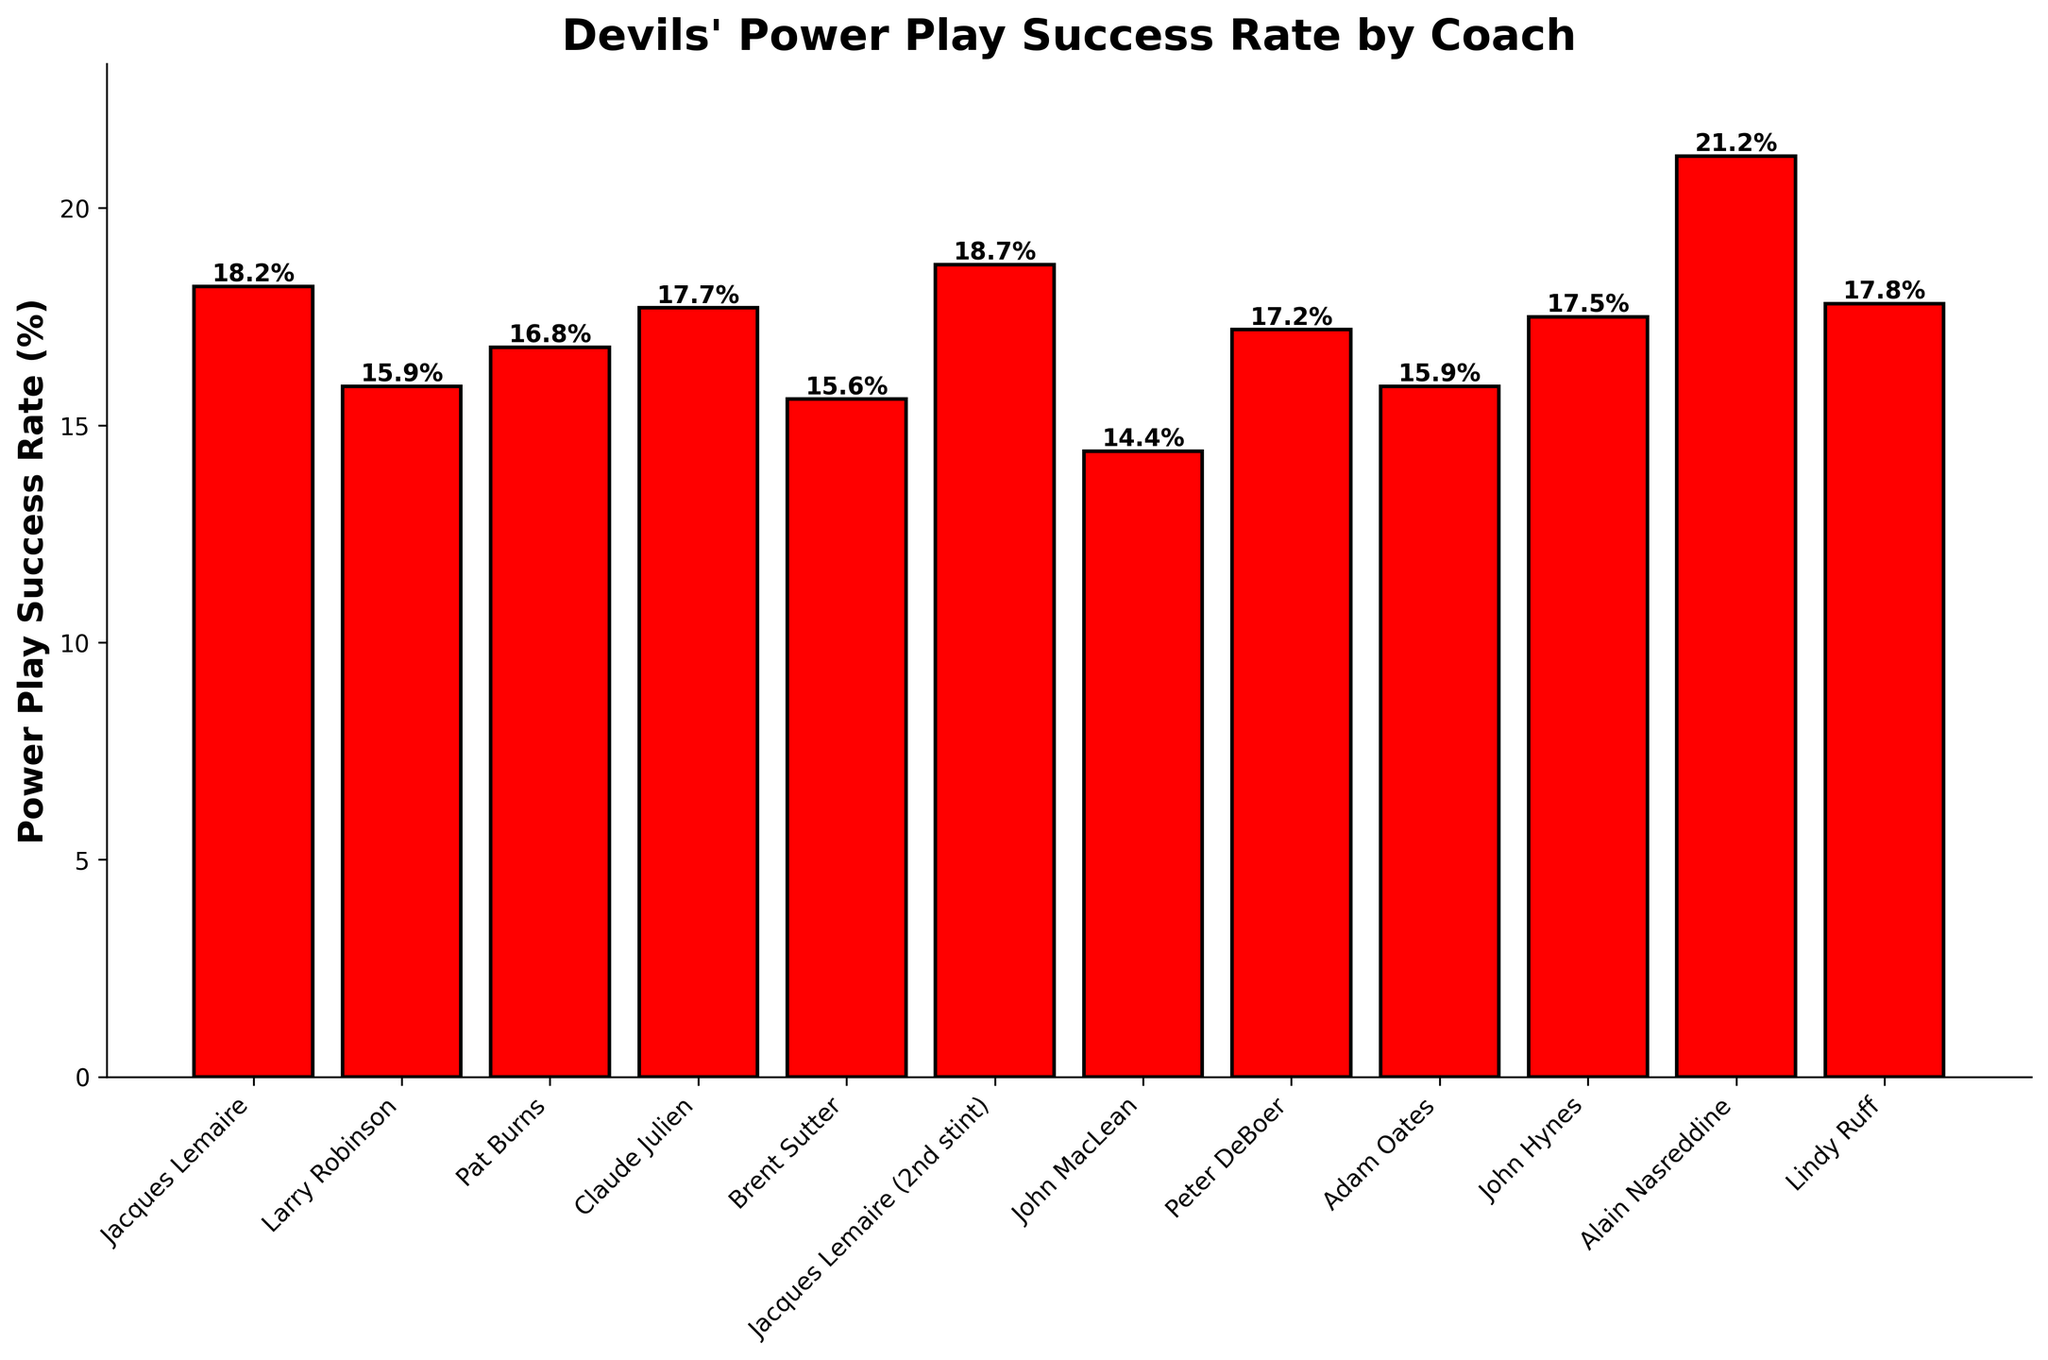Which coach had the highest power play success rate? To answer this, look at the heights of the bars. The highest bar represents the highest power play success rate. On this plot, the highest bar is labeled "Alain Nasreddine" with a success rate of 21.2%.
Answer: Alain Nasreddine What is the difference in power play success rates between Jacques Lemaire's first and second stints? Compare the heights of the two bars labeled "Jacques Lemaire" and "Jacques Lemaire (2nd stint)". First stint is 18.2% and second stint is 18.7%. The difference is 18.7% - 18.2% = 0.5%.
Answer: 0.5% Among Larry Robinson, Pat Burns, and Peter DeBoer, who had the lowest power play success rate? Compare the heights of the three bars labeled "Larry Robinson", "Pat Burns", and "Peter DeBoer". Their success rates are 15.9%, 16.8%, and 17.2%, respectively. The lowest is 15.9%, which belongs to Larry Robinson.
Answer: Larry Robinson Calculate the average power play success rate of all coaches. To find the average, add up all the success rates and divide by the number of coaches. The rates are 18.2%, 15.9%, 16.8%, 17.7%, 15.6%, 18.7%, 14.4%, 17.2%, 15.9%, 17.5%, 21.2%, 17.8%. Sum is 206.9%, and there are 12 coaches. The average is 206.9% / 12 ≈ 17.2%.
Answer: 17.2% Which coach had a power play success rate closest to 17.5%? Identify the bar that is closest in height to the line at 17.5%. The bars for Peter DeBoer (17.2%), John Hynes (17.5%), and Lindy Ruff (17.8%) are closest. John Hynes exactly matches 17.5%.
Answer: John Hynes Is the power play success rate of Brent Sutter higher or lower than Adam Oates? Compare the height of the bars labeled "Brent Sutter" and "Adam Oates". Brent Sutter has a success rate of 15.6% and Adam Oates has 15.9%. Brent Sutter's rate is lower.
Answer: Lower Who had a better power play success rate, John MacLean or Claude Julien? Compare the heights of the bars labeled "John MacLean" and "Claude Julien". John MacLean has a success rate of 14.4% while Claude Julien has 17.7%. Claude Julien's rate is higher.
Answer: Claude Julien Which coach had almost the same power play success rate as Lindy Ruff? Look for the bar heights near Lindy Ruff's rate of 17.8%. The bars for John Hynes (17.5%) and Peter DeBoer (17.2%) are close, but John Hynes (17.5%) is closer.
Answer: John Hynes 